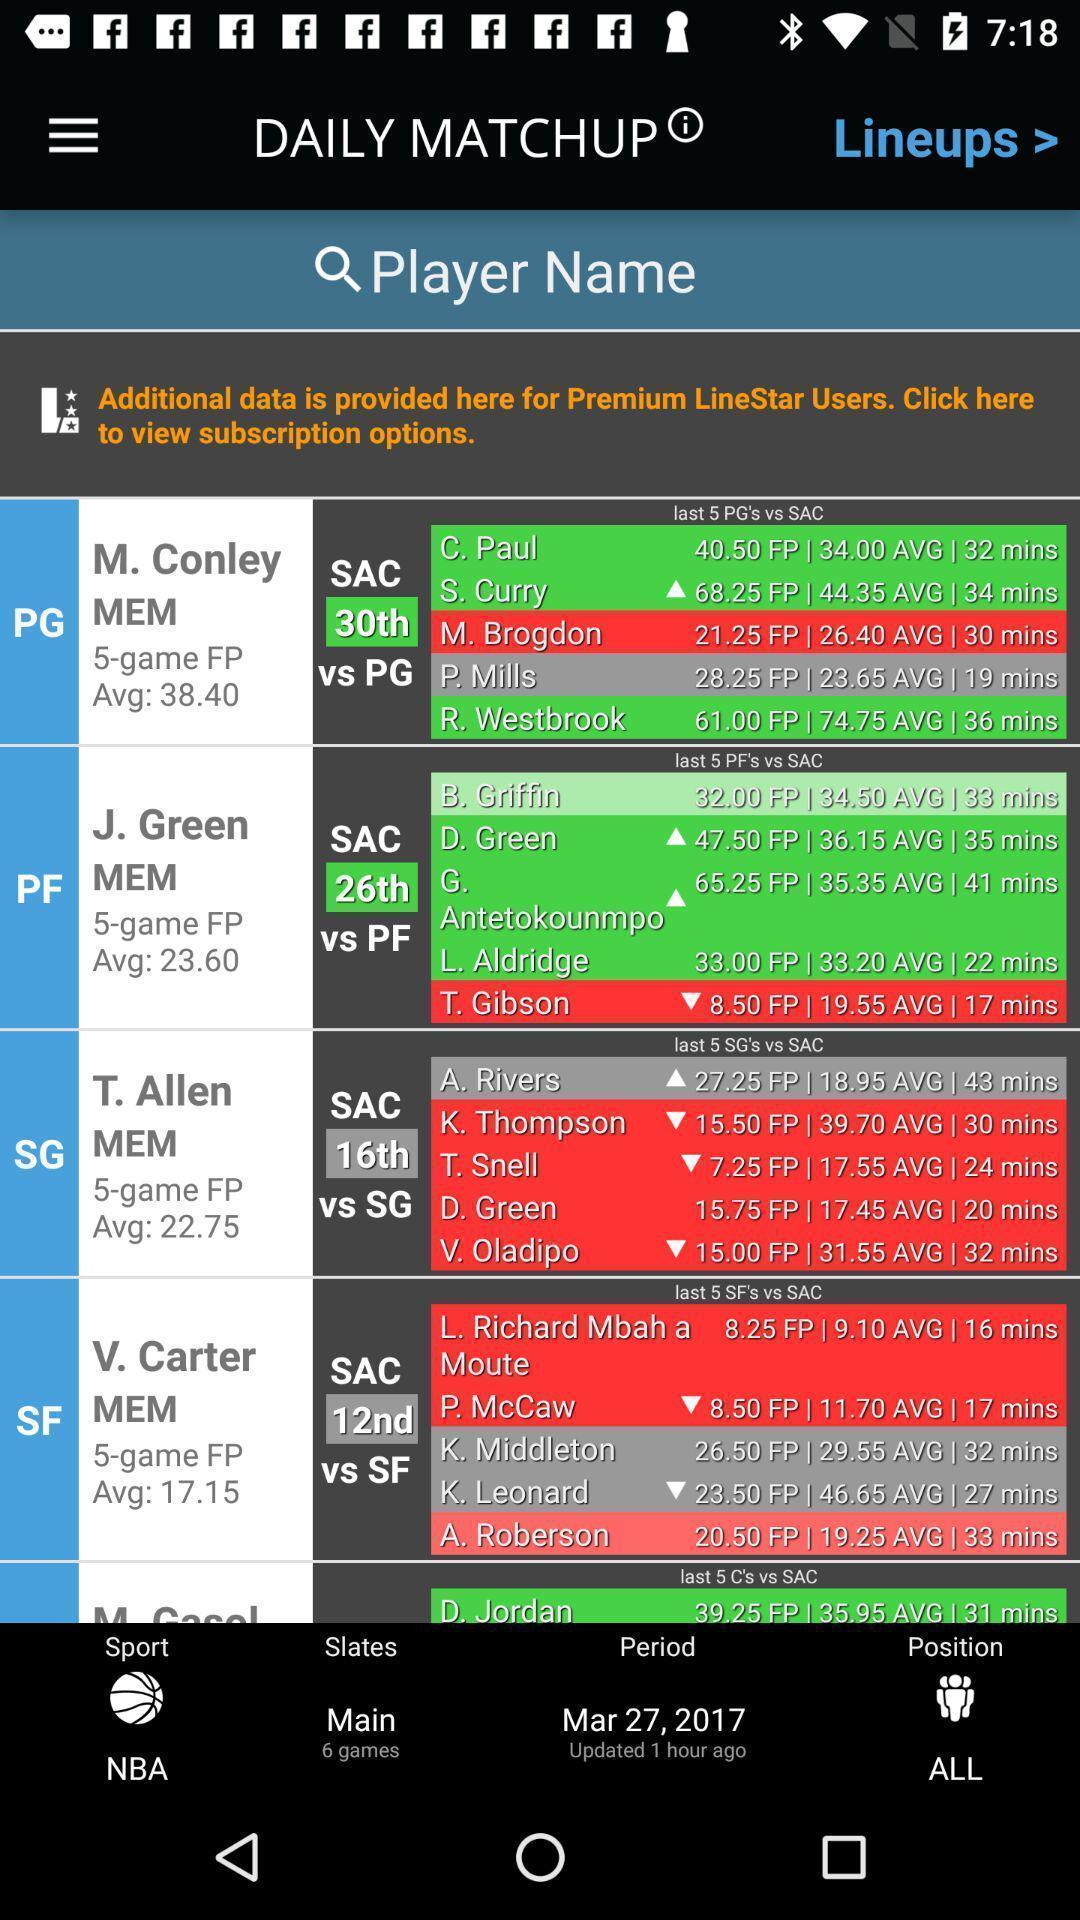What details can you identify in this image? Page displaying the details of sports people. 